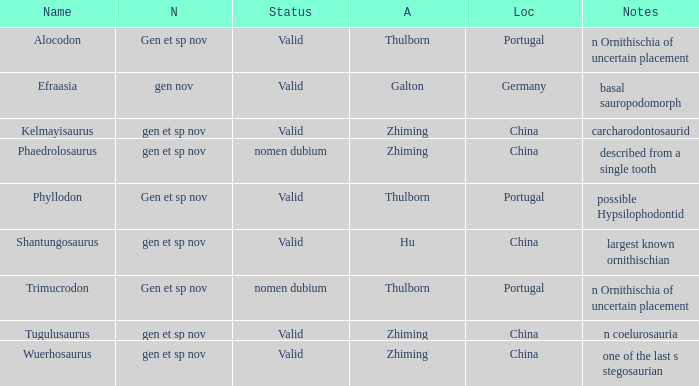What is the Name of the dinosaur, whose notes are, "n ornithischia of uncertain placement"? Alocodon, Trimucrodon. 